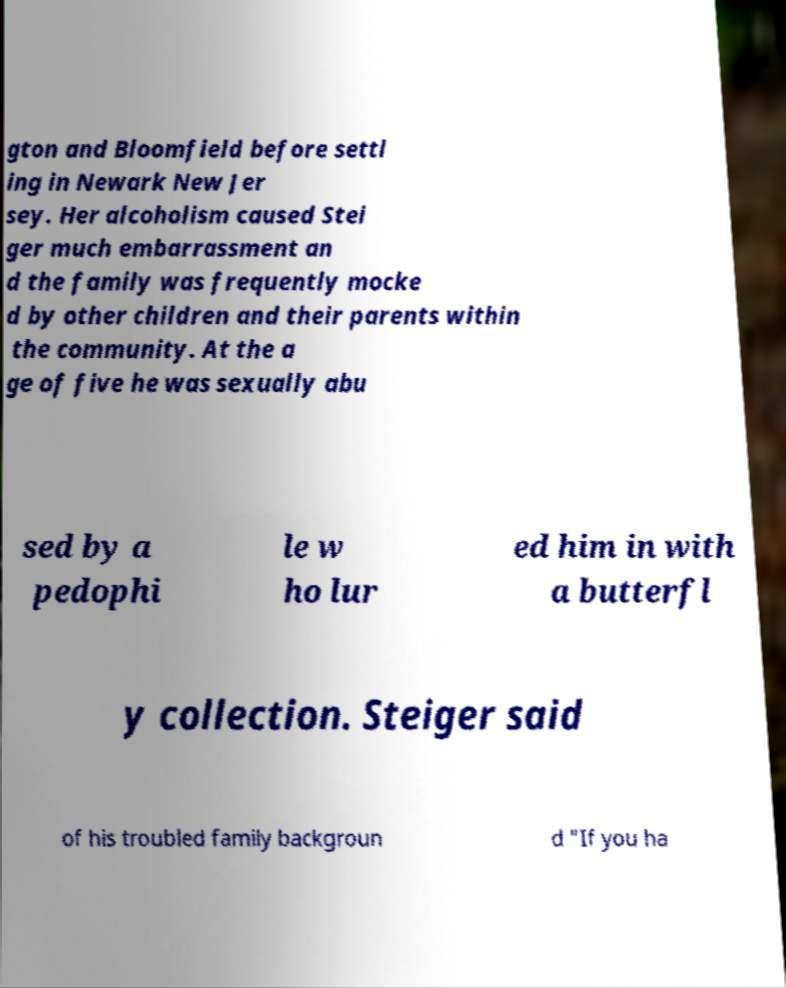For documentation purposes, I need the text within this image transcribed. Could you provide that? gton and Bloomfield before settl ing in Newark New Jer sey. Her alcoholism caused Stei ger much embarrassment an d the family was frequently mocke d by other children and their parents within the community. At the a ge of five he was sexually abu sed by a pedophi le w ho lur ed him in with a butterfl y collection. Steiger said of his troubled family backgroun d "If you ha 